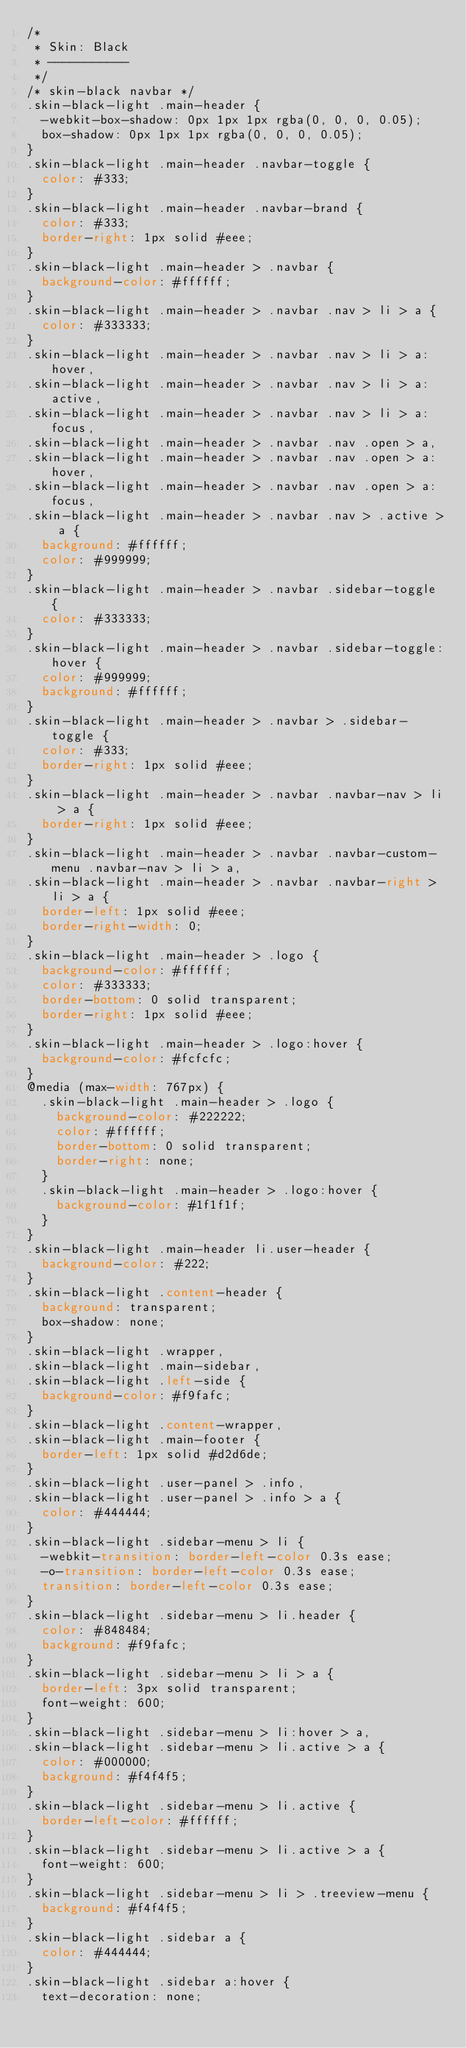<code> <loc_0><loc_0><loc_500><loc_500><_CSS_>/*
 * Skin: Black
 * -----------
 */
/* skin-black navbar */
.skin-black-light .main-header {
  -webkit-box-shadow: 0px 1px 1px rgba(0, 0, 0, 0.05);
  box-shadow: 0px 1px 1px rgba(0, 0, 0, 0.05);
}
.skin-black-light .main-header .navbar-toggle {
  color: #333;
}
.skin-black-light .main-header .navbar-brand {
  color: #333;
  border-right: 1px solid #eee;
}
.skin-black-light .main-header > .navbar {
  background-color: #ffffff;
}
.skin-black-light .main-header > .navbar .nav > li > a {
  color: #333333;
}
.skin-black-light .main-header > .navbar .nav > li > a:hover,
.skin-black-light .main-header > .navbar .nav > li > a:active,
.skin-black-light .main-header > .navbar .nav > li > a:focus,
.skin-black-light .main-header > .navbar .nav .open > a,
.skin-black-light .main-header > .navbar .nav .open > a:hover,
.skin-black-light .main-header > .navbar .nav .open > a:focus,
.skin-black-light .main-header > .navbar .nav > .active > a {
  background: #ffffff;
  color: #999999;
}
.skin-black-light .main-header > .navbar .sidebar-toggle {
  color: #333333;
}
.skin-black-light .main-header > .navbar .sidebar-toggle:hover {
  color: #999999;
  background: #ffffff;
}
.skin-black-light .main-header > .navbar > .sidebar-toggle {
  color: #333;
  border-right: 1px solid #eee;
}
.skin-black-light .main-header > .navbar .navbar-nav > li > a {
  border-right: 1px solid #eee;
}
.skin-black-light .main-header > .navbar .navbar-custom-menu .navbar-nav > li > a,
.skin-black-light .main-header > .navbar .navbar-right > li > a {
  border-left: 1px solid #eee;
  border-right-width: 0;
}
.skin-black-light .main-header > .logo {
  background-color: #ffffff;
  color: #333333;
  border-bottom: 0 solid transparent;
  border-right: 1px solid #eee;
}
.skin-black-light .main-header > .logo:hover {
  background-color: #fcfcfc;
}
@media (max-width: 767px) {
  .skin-black-light .main-header > .logo {
    background-color: #222222;
    color: #ffffff;
    border-bottom: 0 solid transparent;
    border-right: none;
  }
  .skin-black-light .main-header > .logo:hover {
    background-color: #1f1f1f;
  }
}
.skin-black-light .main-header li.user-header {
  background-color: #222;
}
.skin-black-light .content-header {
  background: transparent;
  box-shadow: none;
}
.skin-black-light .wrapper,
.skin-black-light .main-sidebar,
.skin-black-light .left-side {
  background-color: #f9fafc;
}
.skin-black-light .content-wrapper,
.skin-black-light .main-footer {
  border-left: 1px solid #d2d6de;
}
.skin-black-light .user-panel > .info,
.skin-black-light .user-panel > .info > a {
  color: #444444;
}
.skin-black-light .sidebar-menu > li {
  -webkit-transition: border-left-color 0.3s ease;
  -o-transition: border-left-color 0.3s ease;
  transition: border-left-color 0.3s ease;
}
.skin-black-light .sidebar-menu > li.header {
  color: #848484;
  background: #f9fafc;
}
.skin-black-light .sidebar-menu > li > a {
  border-left: 3px solid transparent;
  font-weight: 600;
}
.skin-black-light .sidebar-menu > li:hover > a,
.skin-black-light .sidebar-menu > li.active > a {
  color: #000000;
  background: #f4f4f5;
}
.skin-black-light .sidebar-menu > li.active {
  border-left-color: #ffffff;
}
.skin-black-light .sidebar-menu > li.active > a {
  font-weight: 600;
}
.skin-black-light .sidebar-menu > li > .treeview-menu {
  background: #f4f4f5;
}
.skin-black-light .sidebar a {
  color: #444444;
}
.skin-black-light .sidebar a:hover {
  text-decoration: none;</code> 